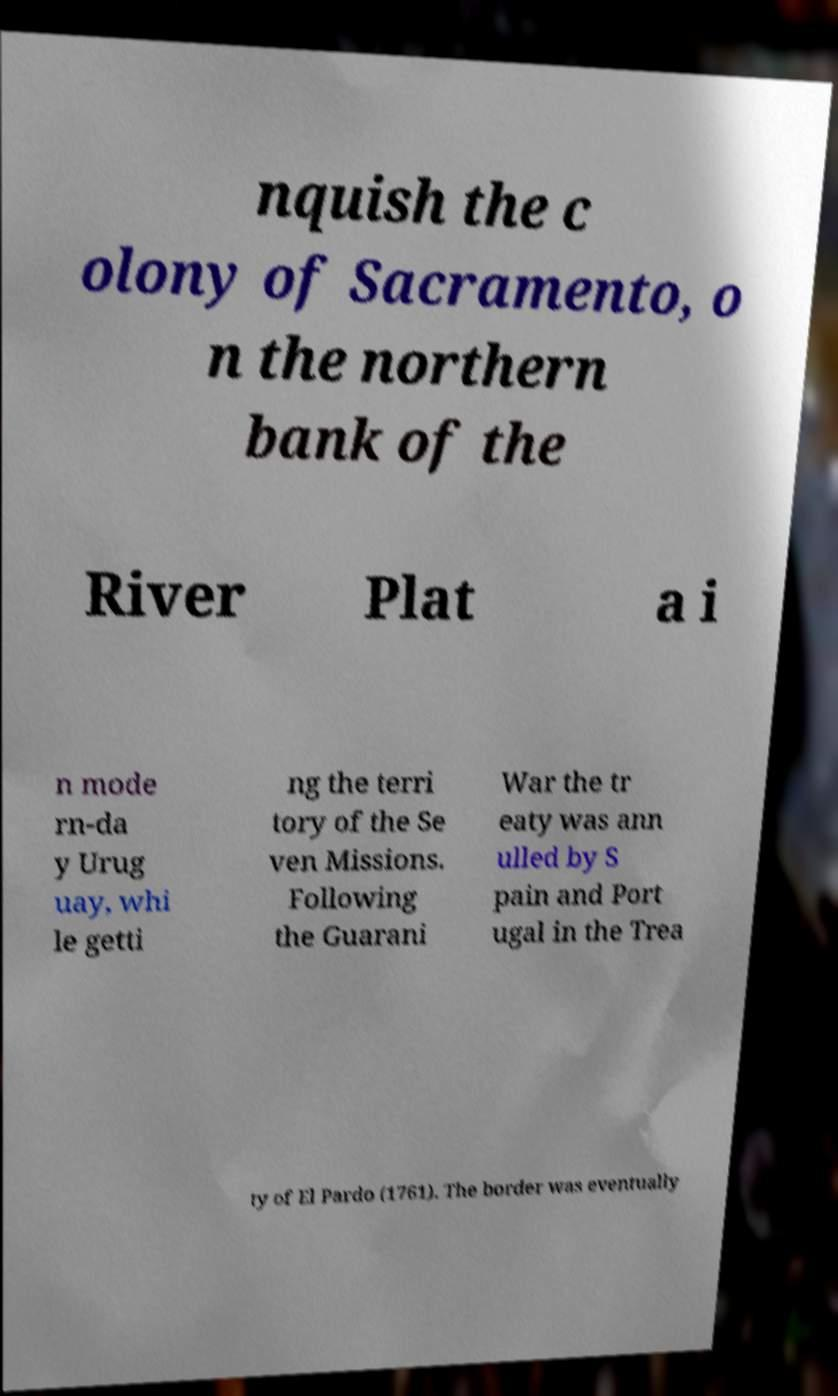Can you accurately transcribe the text from the provided image for me? nquish the c olony of Sacramento, o n the northern bank of the River Plat a i n mode rn-da y Urug uay, whi le getti ng the terri tory of the Se ven Missions. Following the Guarani War the tr eaty was ann ulled by S pain and Port ugal in the Trea ty of El Pardo (1761). The border was eventually 